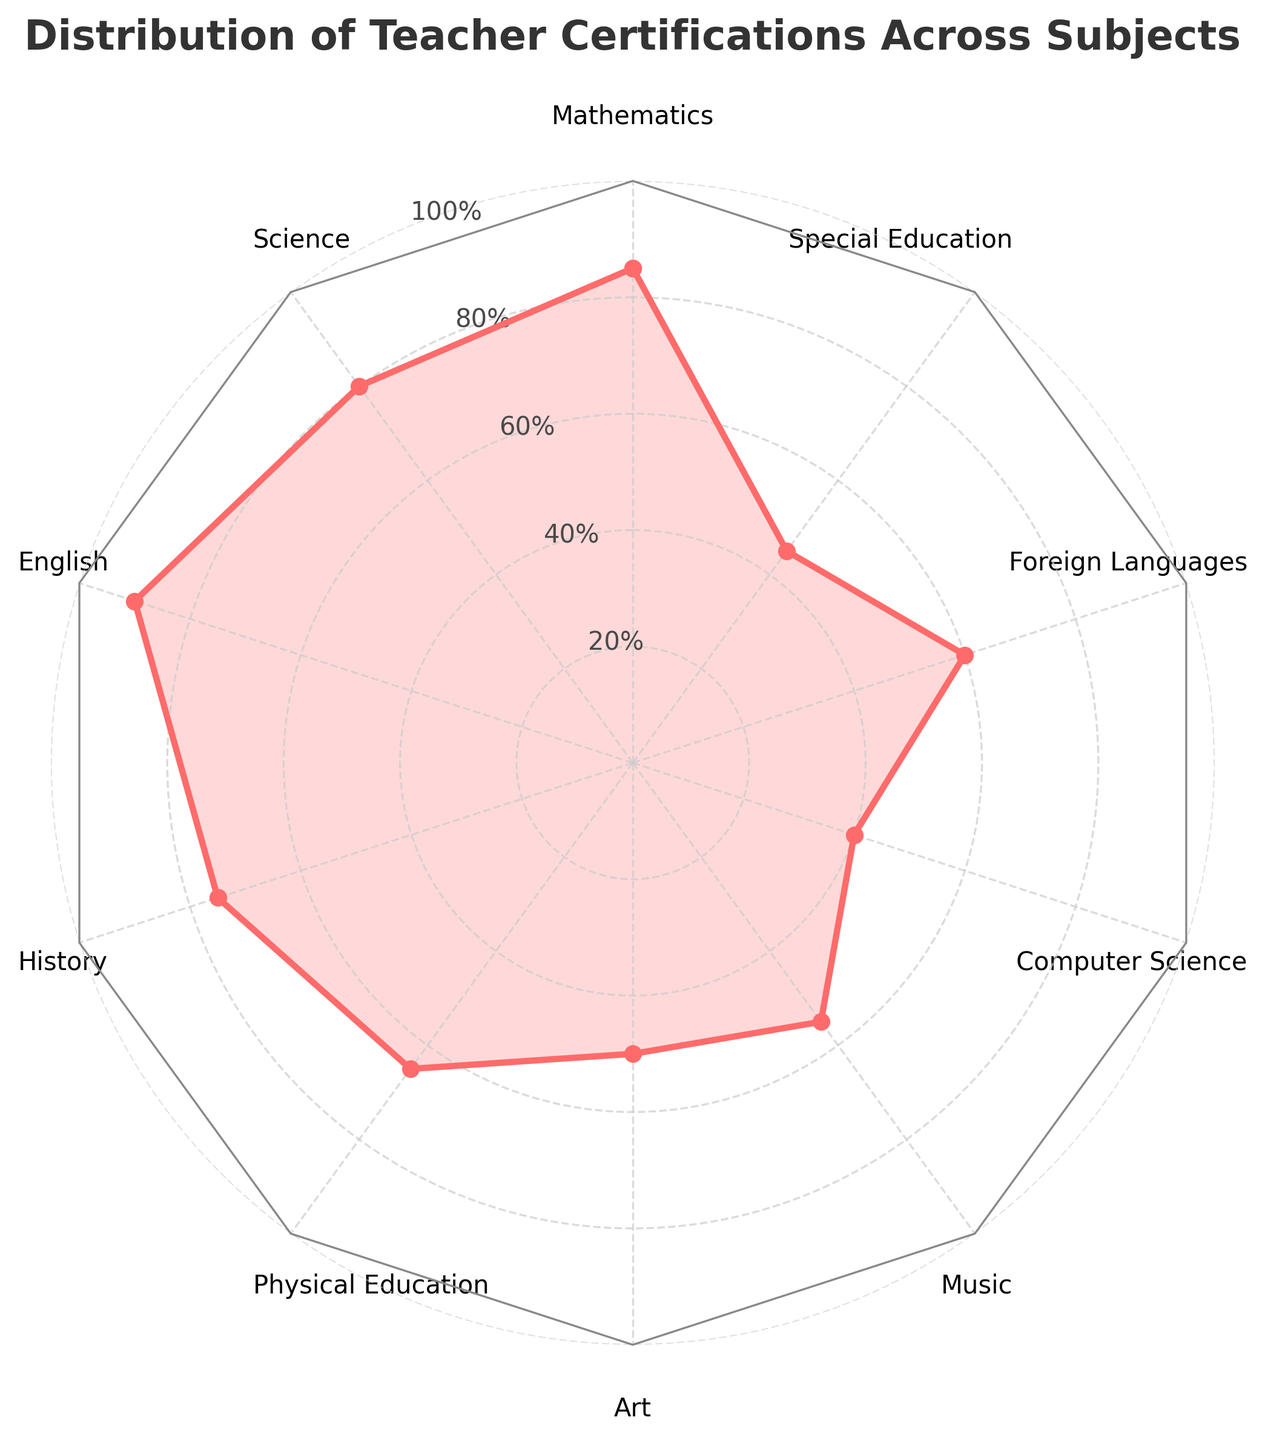How many subjects are represented in the radar chart? The radar chart displays a distinct segment for each subject around the circumference. Counting these segments gives the number of subjects.
Answer: 10 Which subject has the highest number of certified teachers? By looking at the values plotted for each subject on the radar chart, the highest point corresponds to the subject with the highest number of certified teachers.
Answer: English What is the range of certified teachers across all subjects? The range is calculated by subtracting the smallest value from the largest value. Here, the smallest value is 40 (Computer Science) and the largest is 90 (English).
Answer: 50 Which subjects have fewer than 50 certified teachers? By inspecting each point on the radar chart and comparing it to the 50 mark on the scale, we identify the subjects below this threshold.
Answer: Art, Music, Computer Science, Special Education What is the average number of certified teachers across all subjects? Sum all certified teacher values and divide by the number of subjects: (85+80+90+75+65+50+55+40+60+45)/10 = 64.5
Answer: 64.5 Which subject has the lowest number of certified teachers? Find the minimum value of certified teachers on the radar chart. The lowest point corresponds to the subject with the least number of certified teachers.
Answer: Computer Science How does the number of certified teachers in Physical Education compare to that in Science? Locate and compare the values for Physical Education and Science on the radar chart. Physical Education has 65, and Science has 80.
Answer: Science has 15 more What is the median number of certified teachers among all subjects? Arrange the subject values in ascending order (40, 45, 50, 55, 60, 65, 75, 80, 85, 90) and find the middle value. With an even number of subjects, average the 5th and 6th values: (60+65)/2
Answer: 62.5 What is the difference in the number of certified teachers between History and Physical Education? Look at the values for History (75) and Physical Education (65) and subtract the smaller from the larger one.
Answer: 10 How many subjects have a number of certified teachers above 70? By checking each segment on the radar chart and counting those with values greater than 70.
Answer: 4 